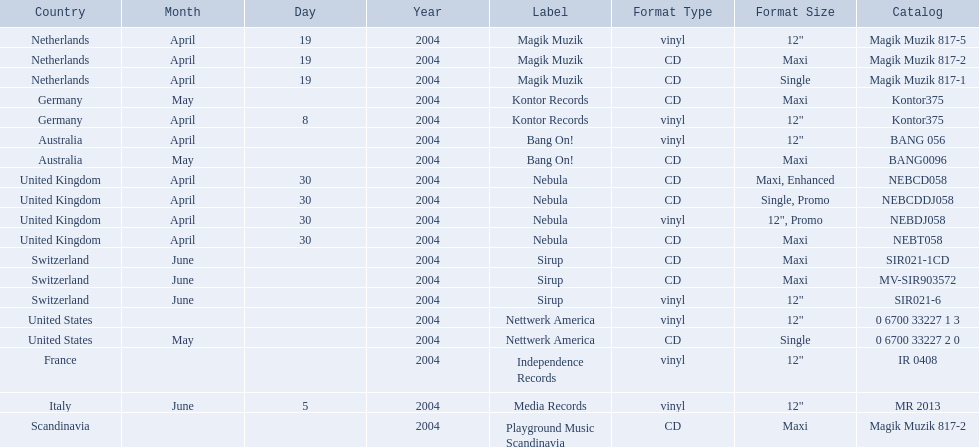What are the labels for love comes again? Magik Muzik, Magik Muzik, Magik Muzik, Kontor Records, Kontor Records, Bang On!, Bang On!, Nebula, Nebula, Nebula, Nebula, Sirup, Sirup, Sirup, Nettwerk America, Nettwerk America, Independence Records, Media Records, Playground Music Scandinavia. What label has been used by the region of france? Independence Records. 